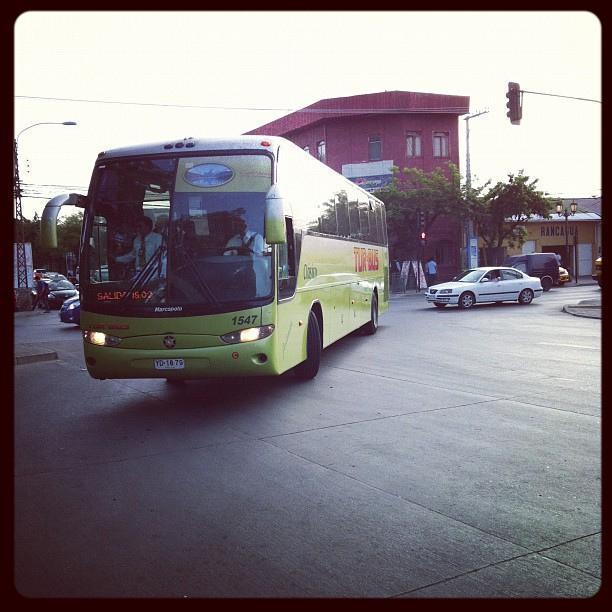What make of vehicle is following the bus?
From the following set of four choices, select the accurate answer to respond to the question.
Options: Kia, mazda, nissan, hyundai. Hyundai. 